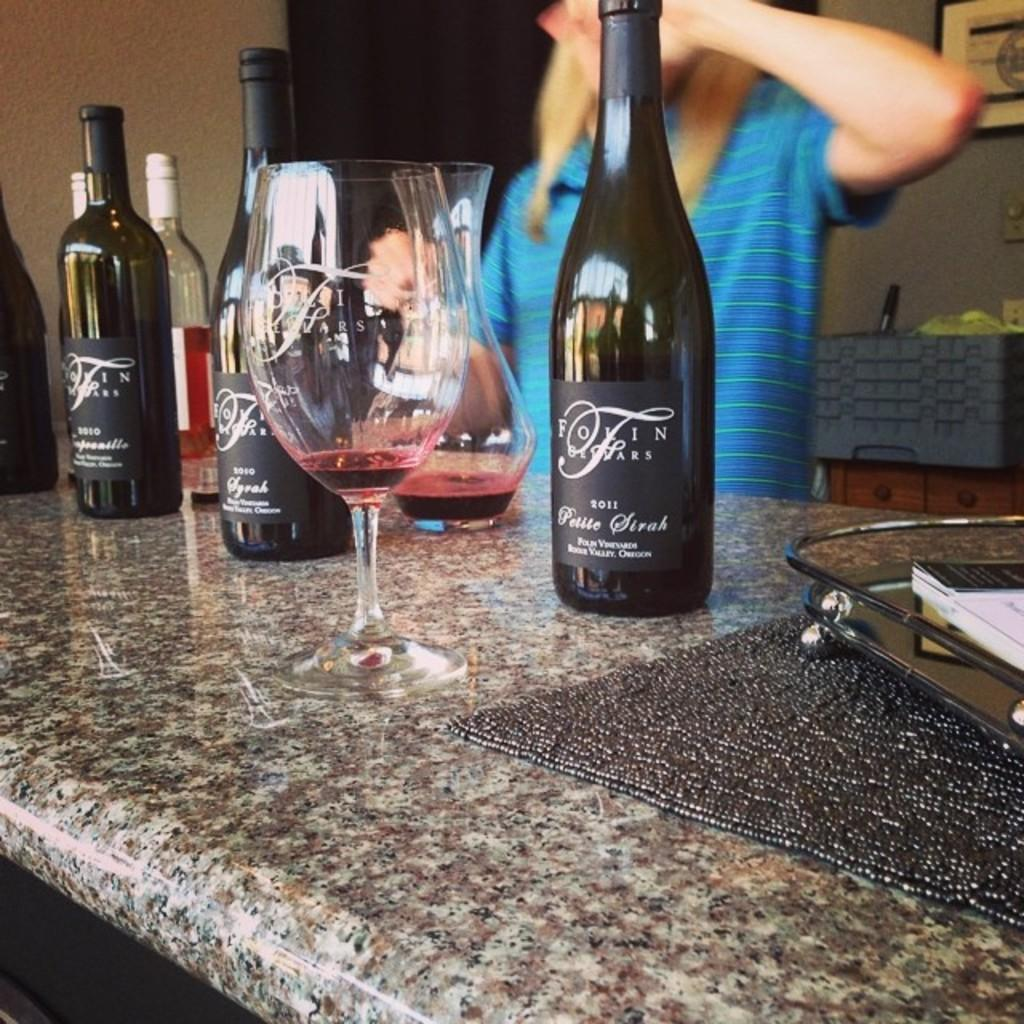What is the position of the person in the image? There is a person standing behind the table in the image. What objects are on the table? There are bottles and glasses on the table. Is there any decoration or item on the wall? Yes, there is a frame on the wall. What type of teeth can be seen in the image? There are no teeth visible in the image. Can you describe the house in the image? There is no house present in the image. 